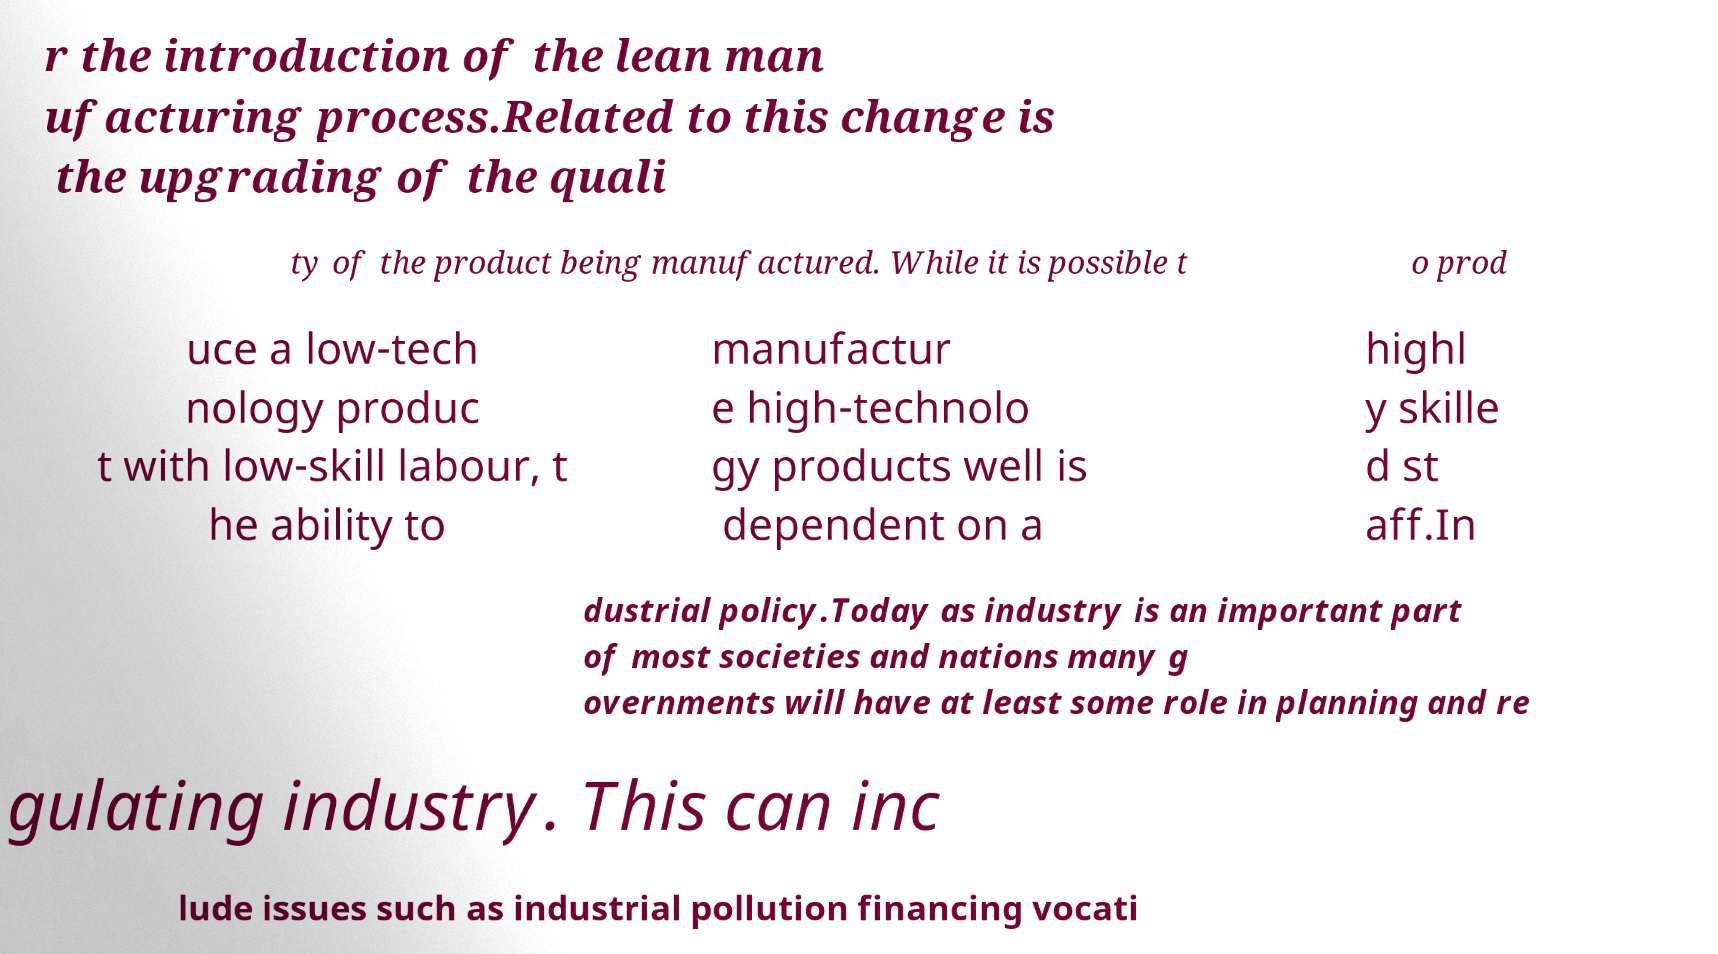Please read and relay the text visible in this image. What does it say? r the introduction of the lean man ufacturing process.Related to this change is the upgrading of the quali ty of the product being manufactured. While it is possible t o prod uce a low-tech nology produc t with low-skill labour, t he ability to manufactur e high-technolo gy products well is dependent on a highl y skille d st aff.In dustrial policy.Today as industry is an important part of most societies and nations many g overnments will have at least some role in planning and re gulating industry. This can inc lude issues such as industrial pollution financing vocati 